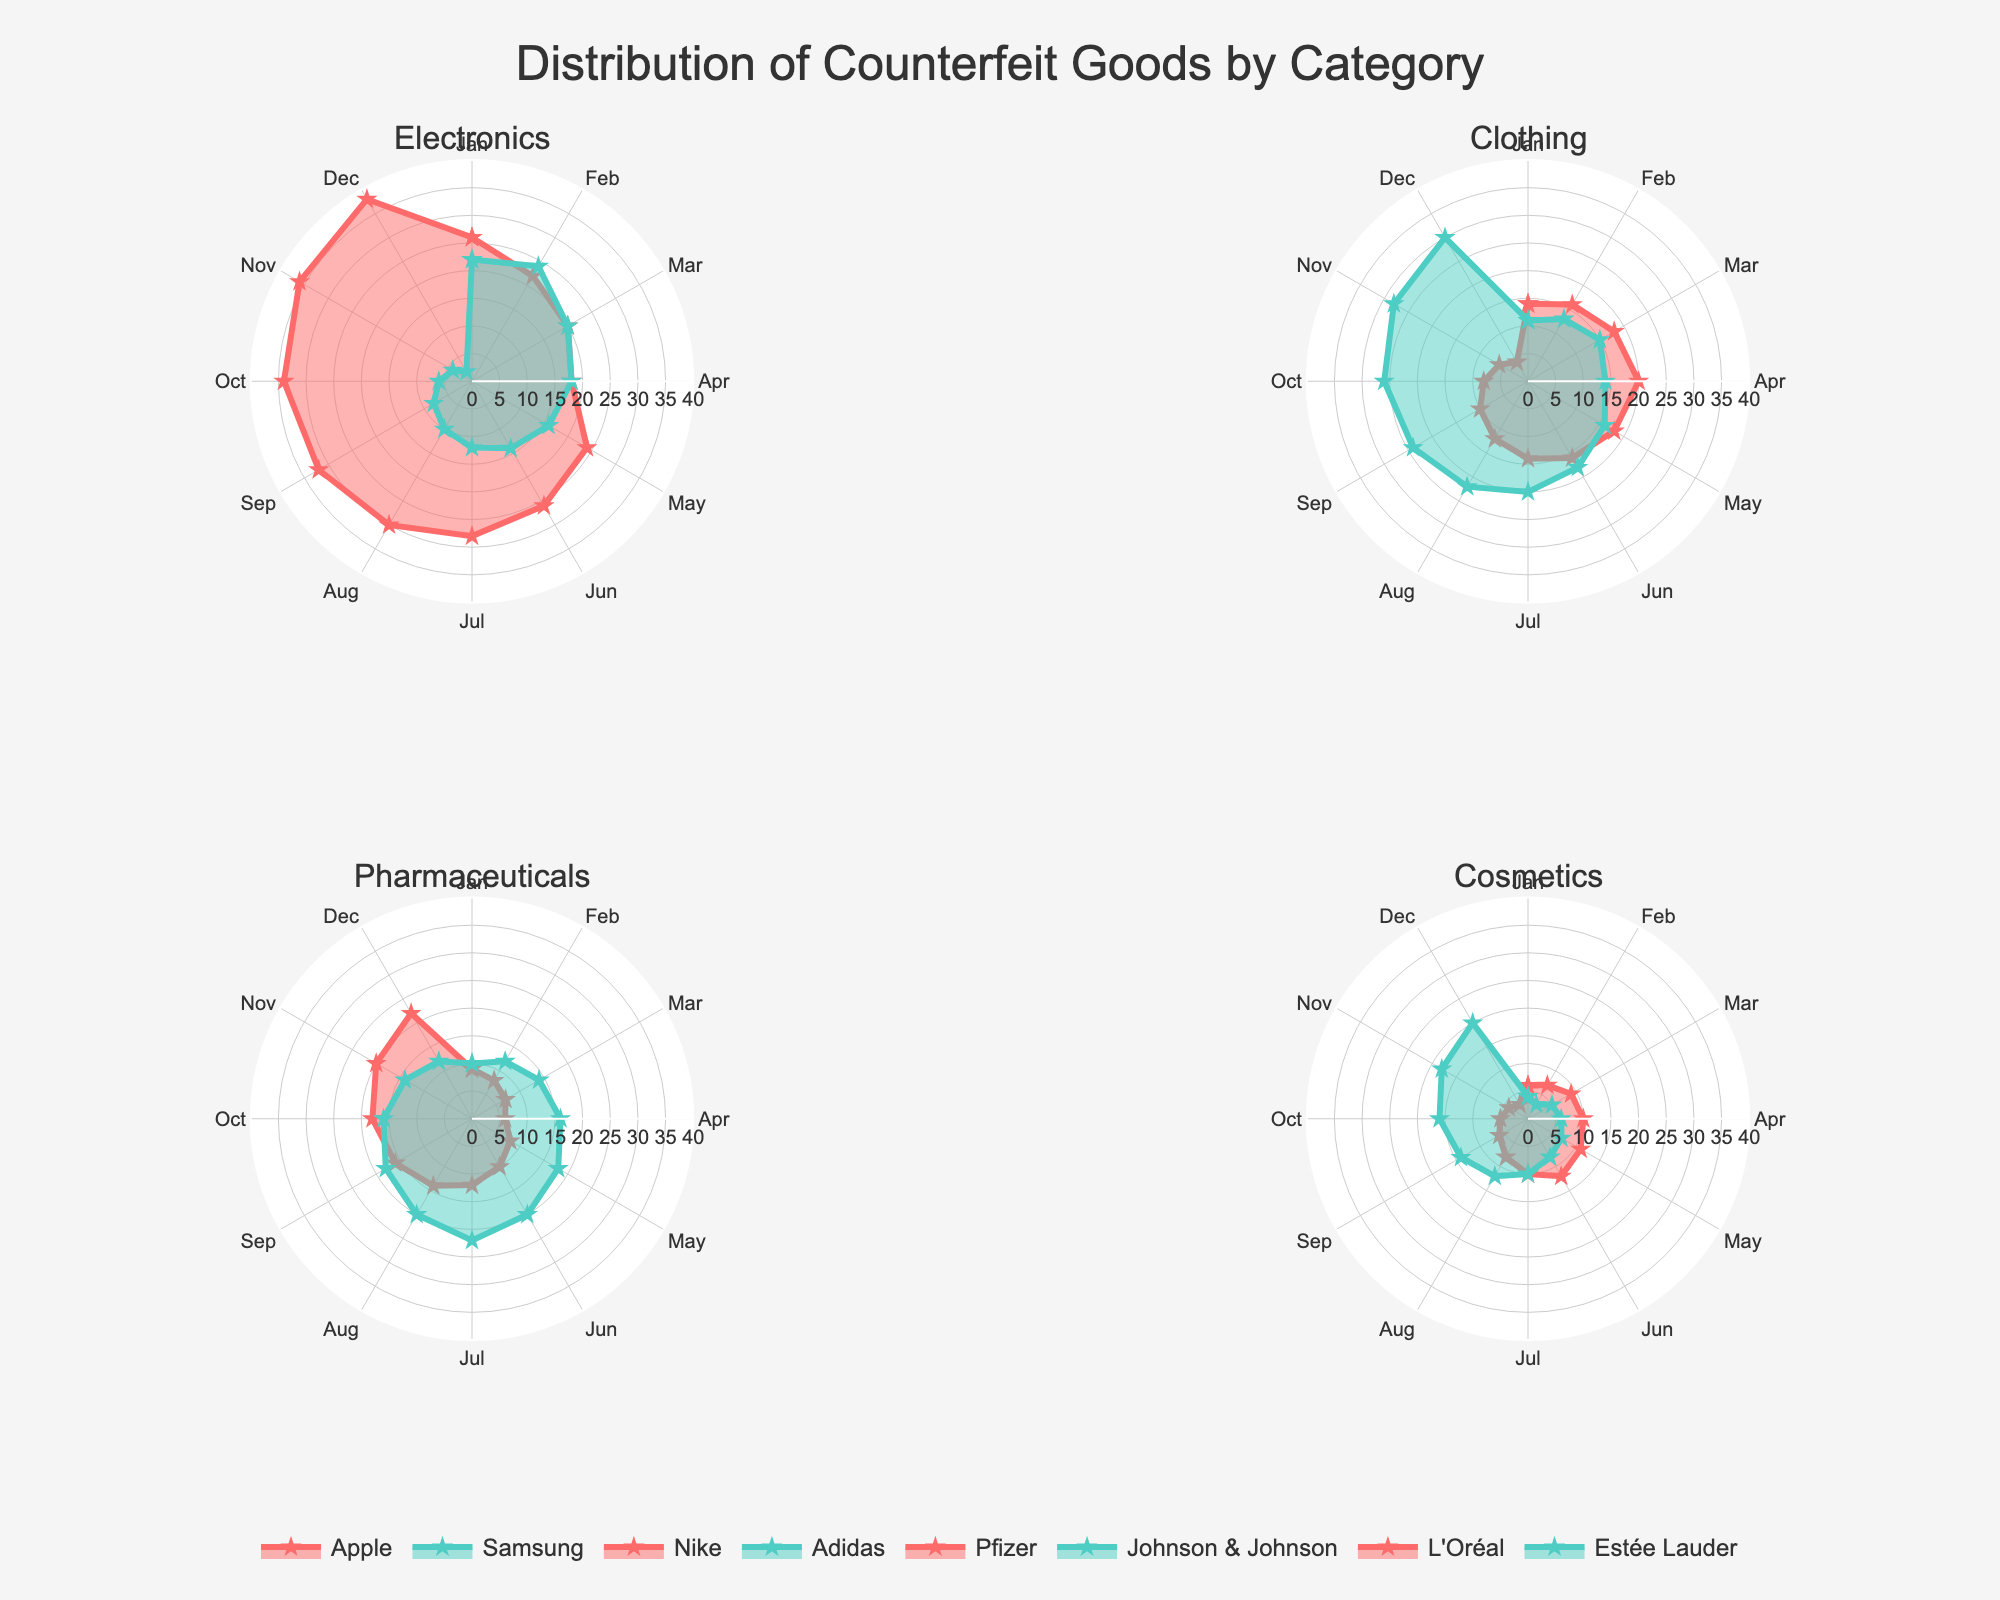How many categories are displayed in the radar chart? The radar chart consists of four subplots, each representing a different category. The titles of the subplots correspond to the categories: Electronics, Clothing, Pharmaceuticals, and Cosmetics.
Answer: 4 Which brand in the "Electronics" category had the lowest detection percentage in December? The subplot for Electronics shows two series, one for Apple and the other for Samsung. The value at the December point for Apple is higher than that for Samsung. Therefore, Samsung has the lowest detection percentage in December.
Answer: Samsung Between Nike and Adidas in the "Clothing" category, which brand saw a general decrease in detection percentage over the year? In the Clothing subplot, the trend lines for both brands can be observed. Nike starts at a higher point and generally decreases through the year, whereas Adidas shows a generally increasing trend toward the end of the year.
Answer: Nike What is the range of detection percentages for Johnson & Johnson in the "Pharmaceuticals" category? The plot for the "Pharmaceuticals" category displays lines for Pfizer and Johnson & Johnson. Johnson & Johnson's detection percentage varies between 10 and 22 throughout the year as observed from its plotted values.
Answer: 10 to 22 Which month shows the highest detection percentage for Apple in the "Electronics" category? Observing the data points for Apple on the radar chart for Electronics, the highest value occurs in December.
Answer: December How does the trend for Estée Lauder in the "Cosmetics" category compare to that of L'Oréal? In the Cosmetics subplot, Estée Lauder shows an increasing trend from January to December, while L'Oréal shows a peak mid-year and then declines. Therefore, Estée Lauder's trend is generally increasing, while L'Oréal's trend is first increasing and then decreasing.
Answer: Estée Lauder: Increasing, L'Oréal: Increasing then decreasing Which brand has the highest detection percentage in November across all categories? By checking the values at November points across all subplots, Apple in the Electronics category shows the highest value.
Answer: Apple On average, how stable was the detection percentage for Pfizer throughout the year in the "Pharmaceuticals" category? Pfizer's values fluctuate between 6 and 22, showing a general upward trend with some variability. To determine stability precisely would require calculating the standard deviation, but visually, it appears moderately unstable.
Answer: Moderately unstable What is the common characteristic of the trend lines for brands in the "Clothing" category? Both trend lines for Nike and Adidas fluctuate over the months, but Nike tends to decrease while Adidas generally increases. The common characteristic is that they both show variability, but in opposite directions.
Answer: Variable trends, opposite directions 